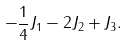Convert formula to latex. <formula><loc_0><loc_0><loc_500><loc_500>- \frac { 1 } { 4 } J _ { 1 } - 2 J _ { 2 } + J _ { 3 } .</formula> 